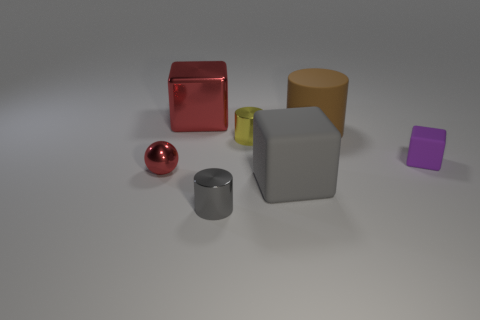What number of other objects are the same shape as the small red metallic object?
Your response must be concise. 0. What is the size of the gray shiny thing that is the same shape as the small yellow object?
Your answer should be compact. Small. There is a tiny object that is the same shape as the large red object; what is its color?
Give a very brief answer. Purple. What number of metal things are the same color as the tiny ball?
Provide a succinct answer. 1. What is the shape of the shiny thing that is both on the left side of the small gray shiny cylinder and in front of the tiny yellow metallic cylinder?
Your answer should be very brief. Sphere. What number of big red things are the same material as the gray cylinder?
Provide a short and direct response. 1. There is a gray thing to the left of the tiny yellow metallic object; does it have the same shape as the red thing that is in front of the brown thing?
Make the answer very short. No. There is a large block in front of the metallic cube; what is its color?
Offer a terse response. Gray. Are there any large red things that have the same shape as the yellow thing?
Provide a succinct answer. No. What material is the large brown cylinder?
Your response must be concise. Rubber. 